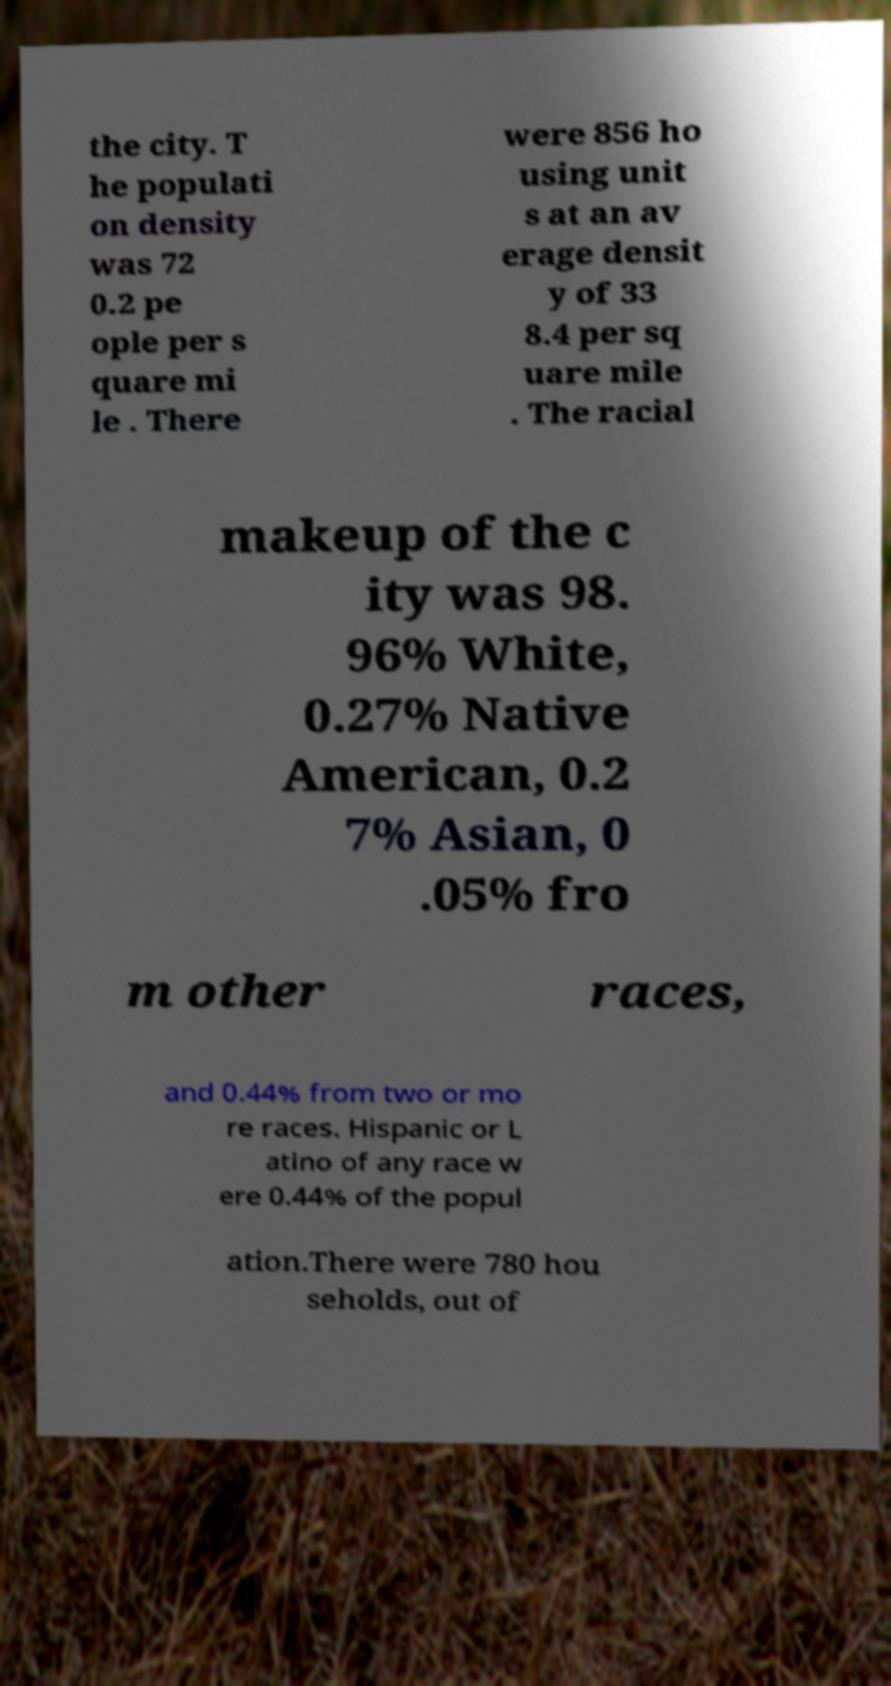Please identify and transcribe the text found in this image. the city. T he populati on density was 72 0.2 pe ople per s quare mi le . There were 856 ho using unit s at an av erage densit y of 33 8.4 per sq uare mile . The racial makeup of the c ity was 98. 96% White, 0.27% Native American, 0.2 7% Asian, 0 .05% fro m other races, and 0.44% from two or mo re races. Hispanic or L atino of any race w ere 0.44% of the popul ation.There were 780 hou seholds, out of 